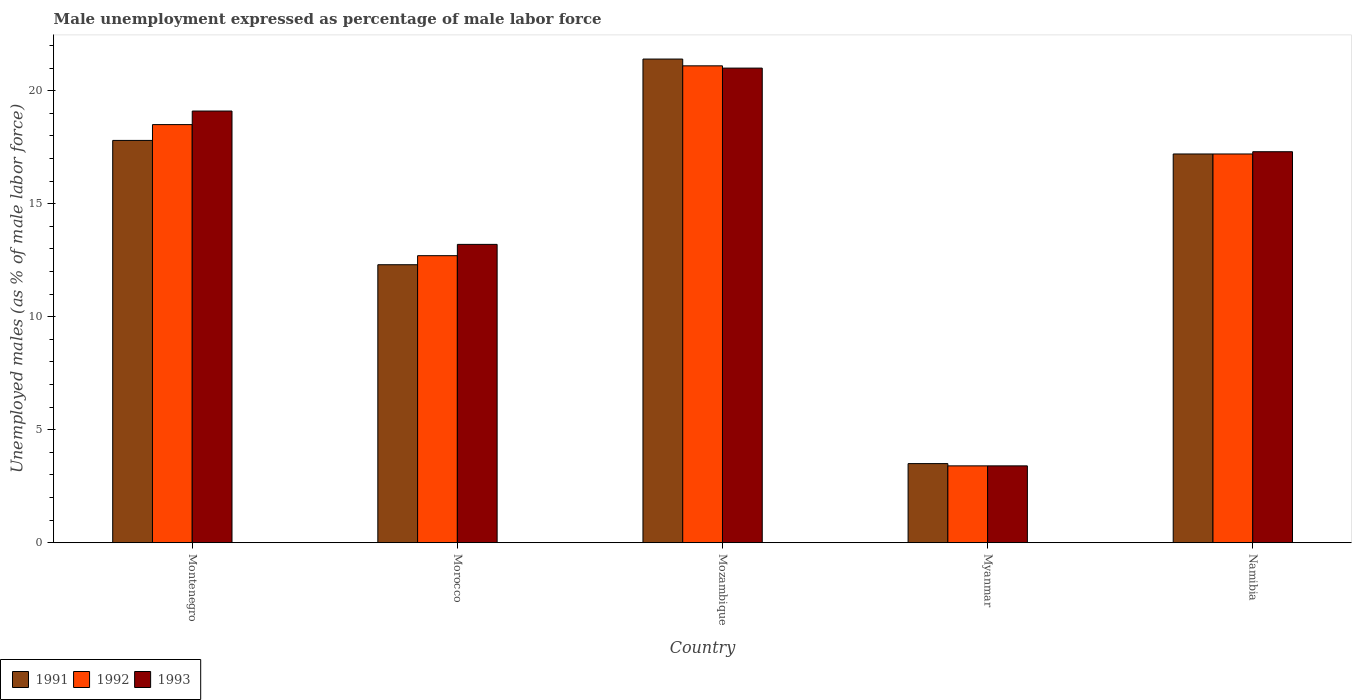Are the number of bars per tick equal to the number of legend labels?
Your response must be concise. Yes. Are the number of bars on each tick of the X-axis equal?
Ensure brevity in your answer.  Yes. How many bars are there on the 3rd tick from the right?
Your response must be concise. 3. What is the label of the 5th group of bars from the left?
Your response must be concise. Namibia. What is the unemployment in males in in 1992 in Myanmar?
Give a very brief answer. 3.4. Across all countries, what is the maximum unemployment in males in in 1993?
Provide a short and direct response. 21. Across all countries, what is the minimum unemployment in males in in 1993?
Your answer should be very brief. 3.4. In which country was the unemployment in males in in 1993 maximum?
Give a very brief answer. Mozambique. In which country was the unemployment in males in in 1993 minimum?
Your answer should be very brief. Myanmar. What is the total unemployment in males in in 1991 in the graph?
Keep it short and to the point. 72.2. What is the difference between the unemployment in males in in 1993 in Mozambique and that in Myanmar?
Your answer should be compact. 17.6. What is the difference between the unemployment in males in in 1993 in Montenegro and the unemployment in males in in 1991 in Myanmar?
Offer a very short reply. 15.6. What is the average unemployment in males in in 1992 per country?
Make the answer very short. 14.58. What is the difference between the unemployment in males in of/in 1992 and unemployment in males in of/in 1993 in Mozambique?
Ensure brevity in your answer.  0.1. What is the ratio of the unemployment in males in in 1991 in Morocco to that in Namibia?
Ensure brevity in your answer.  0.72. What is the difference between the highest and the second highest unemployment in males in in 1993?
Your response must be concise. -1.8. What is the difference between the highest and the lowest unemployment in males in in 1991?
Offer a very short reply. 17.9. What does the 2nd bar from the right in Morocco represents?
Provide a succinct answer. 1992. Is it the case that in every country, the sum of the unemployment in males in in 1993 and unemployment in males in in 1991 is greater than the unemployment in males in in 1992?
Your answer should be compact. Yes. How many bars are there?
Offer a very short reply. 15. Are all the bars in the graph horizontal?
Offer a very short reply. No. How many countries are there in the graph?
Provide a short and direct response. 5. What is the difference between two consecutive major ticks on the Y-axis?
Provide a succinct answer. 5. Are the values on the major ticks of Y-axis written in scientific E-notation?
Your answer should be compact. No. Where does the legend appear in the graph?
Your response must be concise. Bottom left. How many legend labels are there?
Make the answer very short. 3. What is the title of the graph?
Offer a very short reply. Male unemployment expressed as percentage of male labor force. Does "2004" appear as one of the legend labels in the graph?
Offer a very short reply. No. What is the label or title of the Y-axis?
Offer a very short reply. Unemployed males (as % of male labor force). What is the Unemployed males (as % of male labor force) of 1991 in Montenegro?
Your answer should be compact. 17.8. What is the Unemployed males (as % of male labor force) in 1992 in Montenegro?
Give a very brief answer. 18.5. What is the Unemployed males (as % of male labor force) of 1993 in Montenegro?
Your answer should be compact. 19.1. What is the Unemployed males (as % of male labor force) in 1991 in Morocco?
Your answer should be compact. 12.3. What is the Unemployed males (as % of male labor force) of 1992 in Morocco?
Make the answer very short. 12.7. What is the Unemployed males (as % of male labor force) of 1993 in Morocco?
Keep it short and to the point. 13.2. What is the Unemployed males (as % of male labor force) in 1991 in Mozambique?
Provide a short and direct response. 21.4. What is the Unemployed males (as % of male labor force) of 1992 in Mozambique?
Provide a short and direct response. 21.1. What is the Unemployed males (as % of male labor force) in 1993 in Mozambique?
Provide a short and direct response. 21. What is the Unemployed males (as % of male labor force) in 1991 in Myanmar?
Provide a short and direct response. 3.5. What is the Unemployed males (as % of male labor force) in 1992 in Myanmar?
Your response must be concise. 3.4. What is the Unemployed males (as % of male labor force) of 1993 in Myanmar?
Ensure brevity in your answer.  3.4. What is the Unemployed males (as % of male labor force) in 1991 in Namibia?
Your answer should be compact. 17.2. What is the Unemployed males (as % of male labor force) of 1992 in Namibia?
Keep it short and to the point. 17.2. What is the Unemployed males (as % of male labor force) of 1993 in Namibia?
Your answer should be compact. 17.3. Across all countries, what is the maximum Unemployed males (as % of male labor force) in 1991?
Your response must be concise. 21.4. Across all countries, what is the maximum Unemployed males (as % of male labor force) in 1992?
Provide a short and direct response. 21.1. Across all countries, what is the minimum Unemployed males (as % of male labor force) of 1991?
Your response must be concise. 3.5. Across all countries, what is the minimum Unemployed males (as % of male labor force) of 1992?
Ensure brevity in your answer.  3.4. Across all countries, what is the minimum Unemployed males (as % of male labor force) of 1993?
Ensure brevity in your answer.  3.4. What is the total Unemployed males (as % of male labor force) of 1991 in the graph?
Make the answer very short. 72.2. What is the total Unemployed males (as % of male labor force) of 1992 in the graph?
Keep it short and to the point. 72.9. What is the total Unemployed males (as % of male labor force) of 1993 in the graph?
Make the answer very short. 74. What is the difference between the Unemployed males (as % of male labor force) in 1993 in Montenegro and that in Mozambique?
Provide a short and direct response. -1.9. What is the difference between the Unemployed males (as % of male labor force) in 1991 in Montenegro and that in Myanmar?
Ensure brevity in your answer.  14.3. What is the difference between the Unemployed males (as % of male labor force) of 1992 in Montenegro and that in Myanmar?
Provide a succinct answer. 15.1. What is the difference between the Unemployed males (as % of male labor force) of 1993 in Montenegro and that in Myanmar?
Your answer should be compact. 15.7. What is the difference between the Unemployed males (as % of male labor force) of 1991 in Montenegro and that in Namibia?
Keep it short and to the point. 0.6. What is the difference between the Unemployed males (as % of male labor force) of 1992 in Montenegro and that in Namibia?
Make the answer very short. 1.3. What is the difference between the Unemployed males (as % of male labor force) of 1991 in Morocco and that in Mozambique?
Your response must be concise. -9.1. What is the difference between the Unemployed males (as % of male labor force) in 1992 in Morocco and that in Mozambique?
Ensure brevity in your answer.  -8.4. What is the difference between the Unemployed males (as % of male labor force) in 1991 in Morocco and that in Myanmar?
Ensure brevity in your answer.  8.8. What is the difference between the Unemployed males (as % of male labor force) of 1992 in Morocco and that in Namibia?
Offer a terse response. -4.5. What is the difference between the Unemployed males (as % of male labor force) of 1991 in Mozambique and that in Namibia?
Make the answer very short. 4.2. What is the difference between the Unemployed males (as % of male labor force) of 1992 in Mozambique and that in Namibia?
Your answer should be very brief. 3.9. What is the difference between the Unemployed males (as % of male labor force) in 1993 in Mozambique and that in Namibia?
Offer a very short reply. 3.7. What is the difference between the Unemployed males (as % of male labor force) in 1991 in Myanmar and that in Namibia?
Provide a succinct answer. -13.7. What is the difference between the Unemployed males (as % of male labor force) of 1991 in Montenegro and the Unemployed males (as % of male labor force) of 1993 in Morocco?
Give a very brief answer. 4.6. What is the difference between the Unemployed males (as % of male labor force) in 1992 in Montenegro and the Unemployed males (as % of male labor force) in 1993 in Morocco?
Your answer should be very brief. 5.3. What is the difference between the Unemployed males (as % of male labor force) in 1991 in Montenegro and the Unemployed males (as % of male labor force) in 1992 in Myanmar?
Keep it short and to the point. 14.4. What is the difference between the Unemployed males (as % of male labor force) of 1991 in Montenegro and the Unemployed males (as % of male labor force) of 1993 in Myanmar?
Ensure brevity in your answer.  14.4. What is the difference between the Unemployed males (as % of male labor force) of 1991 in Montenegro and the Unemployed males (as % of male labor force) of 1992 in Namibia?
Make the answer very short. 0.6. What is the difference between the Unemployed males (as % of male labor force) of 1991 in Montenegro and the Unemployed males (as % of male labor force) of 1993 in Namibia?
Your answer should be compact. 0.5. What is the difference between the Unemployed males (as % of male labor force) in 1992 in Montenegro and the Unemployed males (as % of male labor force) in 1993 in Namibia?
Offer a very short reply. 1.2. What is the difference between the Unemployed males (as % of male labor force) of 1991 in Morocco and the Unemployed males (as % of male labor force) of 1992 in Mozambique?
Your answer should be very brief. -8.8. What is the difference between the Unemployed males (as % of male labor force) of 1991 in Morocco and the Unemployed males (as % of male labor force) of 1993 in Mozambique?
Your answer should be very brief. -8.7. What is the difference between the Unemployed males (as % of male labor force) in 1991 in Morocco and the Unemployed males (as % of male labor force) in 1992 in Myanmar?
Offer a terse response. 8.9. What is the difference between the Unemployed males (as % of male labor force) of 1992 in Morocco and the Unemployed males (as % of male labor force) of 1993 in Myanmar?
Provide a succinct answer. 9.3. What is the difference between the Unemployed males (as % of male labor force) of 1992 in Morocco and the Unemployed males (as % of male labor force) of 1993 in Namibia?
Ensure brevity in your answer.  -4.6. What is the difference between the Unemployed males (as % of male labor force) of 1991 in Mozambique and the Unemployed males (as % of male labor force) of 1993 in Myanmar?
Ensure brevity in your answer.  18. What is the difference between the Unemployed males (as % of male labor force) of 1991 in Mozambique and the Unemployed males (as % of male labor force) of 1992 in Namibia?
Your answer should be very brief. 4.2. What is the difference between the Unemployed males (as % of male labor force) in 1991 in Mozambique and the Unemployed males (as % of male labor force) in 1993 in Namibia?
Your response must be concise. 4.1. What is the difference between the Unemployed males (as % of male labor force) of 1992 in Mozambique and the Unemployed males (as % of male labor force) of 1993 in Namibia?
Make the answer very short. 3.8. What is the difference between the Unemployed males (as % of male labor force) of 1991 in Myanmar and the Unemployed males (as % of male labor force) of 1992 in Namibia?
Give a very brief answer. -13.7. What is the difference between the Unemployed males (as % of male labor force) of 1991 in Myanmar and the Unemployed males (as % of male labor force) of 1993 in Namibia?
Provide a succinct answer. -13.8. What is the difference between the Unemployed males (as % of male labor force) in 1992 in Myanmar and the Unemployed males (as % of male labor force) in 1993 in Namibia?
Ensure brevity in your answer.  -13.9. What is the average Unemployed males (as % of male labor force) of 1991 per country?
Ensure brevity in your answer.  14.44. What is the average Unemployed males (as % of male labor force) in 1992 per country?
Ensure brevity in your answer.  14.58. What is the average Unemployed males (as % of male labor force) of 1993 per country?
Provide a succinct answer. 14.8. What is the difference between the Unemployed males (as % of male labor force) of 1991 and Unemployed males (as % of male labor force) of 1992 in Montenegro?
Offer a very short reply. -0.7. What is the difference between the Unemployed males (as % of male labor force) of 1991 and Unemployed males (as % of male labor force) of 1993 in Montenegro?
Provide a succinct answer. -1.3. What is the difference between the Unemployed males (as % of male labor force) of 1991 and Unemployed males (as % of male labor force) of 1992 in Morocco?
Your response must be concise. -0.4. What is the difference between the Unemployed males (as % of male labor force) of 1991 and Unemployed males (as % of male labor force) of 1993 in Morocco?
Your answer should be compact. -0.9. What is the difference between the Unemployed males (as % of male labor force) of 1992 and Unemployed males (as % of male labor force) of 1993 in Morocco?
Your answer should be very brief. -0.5. What is the difference between the Unemployed males (as % of male labor force) in 1991 and Unemployed males (as % of male labor force) in 1992 in Mozambique?
Provide a short and direct response. 0.3. What is the difference between the Unemployed males (as % of male labor force) in 1992 and Unemployed males (as % of male labor force) in 1993 in Mozambique?
Ensure brevity in your answer.  0.1. What is the difference between the Unemployed males (as % of male labor force) of 1991 and Unemployed males (as % of male labor force) of 1992 in Myanmar?
Make the answer very short. 0.1. What is the difference between the Unemployed males (as % of male labor force) of 1991 and Unemployed males (as % of male labor force) of 1993 in Myanmar?
Give a very brief answer. 0.1. What is the difference between the Unemployed males (as % of male labor force) of 1992 and Unemployed males (as % of male labor force) of 1993 in Myanmar?
Provide a succinct answer. 0. What is the difference between the Unemployed males (as % of male labor force) of 1991 and Unemployed males (as % of male labor force) of 1992 in Namibia?
Ensure brevity in your answer.  0. What is the difference between the Unemployed males (as % of male labor force) of 1992 and Unemployed males (as % of male labor force) of 1993 in Namibia?
Offer a very short reply. -0.1. What is the ratio of the Unemployed males (as % of male labor force) in 1991 in Montenegro to that in Morocco?
Your answer should be very brief. 1.45. What is the ratio of the Unemployed males (as % of male labor force) in 1992 in Montenegro to that in Morocco?
Your answer should be compact. 1.46. What is the ratio of the Unemployed males (as % of male labor force) of 1993 in Montenegro to that in Morocco?
Provide a succinct answer. 1.45. What is the ratio of the Unemployed males (as % of male labor force) in 1991 in Montenegro to that in Mozambique?
Offer a terse response. 0.83. What is the ratio of the Unemployed males (as % of male labor force) in 1992 in Montenegro to that in Mozambique?
Give a very brief answer. 0.88. What is the ratio of the Unemployed males (as % of male labor force) in 1993 in Montenegro to that in Mozambique?
Your answer should be compact. 0.91. What is the ratio of the Unemployed males (as % of male labor force) of 1991 in Montenegro to that in Myanmar?
Give a very brief answer. 5.09. What is the ratio of the Unemployed males (as % of male labor force) in 1992 in Montenegro to that in Myanmar?
Your answer should be compact. 5.44. What is the ratio of the Unemployed males (as % of male labor force) of 1993 in Montenegro to that in Myanmar?
Offer a terse response. 5.62. What is the ratio of the Unemployed males (as % of male labor force) in 1991 in Montenegro to that in Namibia?
Make the answer very short. 1.03. What is the ratio of the Unemployed males (as % of male labor force) in 1992 in Montenegro to that in Namibia?
Offer a very short reply. 1.08. What is the ratio of the Unemployed males (as % of male labor force) in 1993 in Montenegro to that in Namibia?
Offer a terse response. 1.1. What is the ratio of the Unemployed males (as % of male labor force) in 1991 in Morocco to that in Mozambique?
Offer a terse response. 0.57. What is the ratio of the Unemployed males (as % of male labor force) of 1992 in Morocco to that in Mozambique?
Give a very brief answer. 0.6. What is the ratio of the Unemployed males (as % of male labor force) of 1993 in Morocco to that in Mozambique?
Your answer should be compact. 0.63. What is the ratio of the Unemployed males (as % of male labor force) in 1991 in Morocco to that in Myanmar?
Your answer should be very brief. 3.51. What is the ratio of the Unemployed males (as % of male labor force) of 1992 in Morocco to that in Myanmar?
Your answer should be compact. 3.74. What is the ratio of the Unemployed males (as % of male labor force) of 1993 in Morocco to that in Myanmar?
Your answer should be very brief. 3.88. What is the ratio of the Unemployed males (as % of male labor force) in 1991 in Morocco to that in Namibia?
Your answer should be very brief. 0.72. What is the ratio of the Unemployed males (as % of male labor force) in 1992 in Morocco to that in Namibia?
Your answer should be very brief. 0.74. What is the ratio of the Unemployed males (as % of male labor force) in 1993 in Morocco to that in Namibia?
Your answer should be compact. 0.76. What is the ratio of the Unemployed males (as % of male labor force) of 1991 in Mozambique to that in Myanmar?
Make the answer very short. 6.11. What is the ratio of the Unemployed males (as % of male labor force) in 1992 in Mozambique to that in Myanmar?
Offer a terse response. 6.21. What is the ratio of the Unemployed males (as % of male labor force) in 1993 in Mozambique to that in Myanmar?
Keep it short and to the point. 6.18. What is the ratio of the Unemployed males (as % of male labor force) of 1991 in Mozambique to that in Namibia?
Ensure brevity in your answer.  1.24. What is the ratio of the Unemployed males (as % of male labor force) in 1992 in Mozambique to that in Namibia?
Provide a short and direct response. 1.23. What is the ratio of the Unemployed males (as % of male labor force) in 1993 in Mozambique to that in Namibia?
Provide a short and direct response. 1.21. What is the ratio of the Unemployed males (as % of male labor force) in 1991 in Myanmar to that in Namibia?
Offer a very short reply. 0.2. What is the ratio of the Unemployed males (as % of male labor force) in 1992 in Myanmar to that in Namibia?
Offer a very short reply. 0.2. What is the ratio of the Unemployed males (as % of male labor force) of 1993 in Myanmar to that in Namibia?
Provide a short and direct response. 0.2. What is the difference between the highest and the second highest Unemployed males (as % of male labor force) of 1991?
Provide a succinct answer. 3.6. 